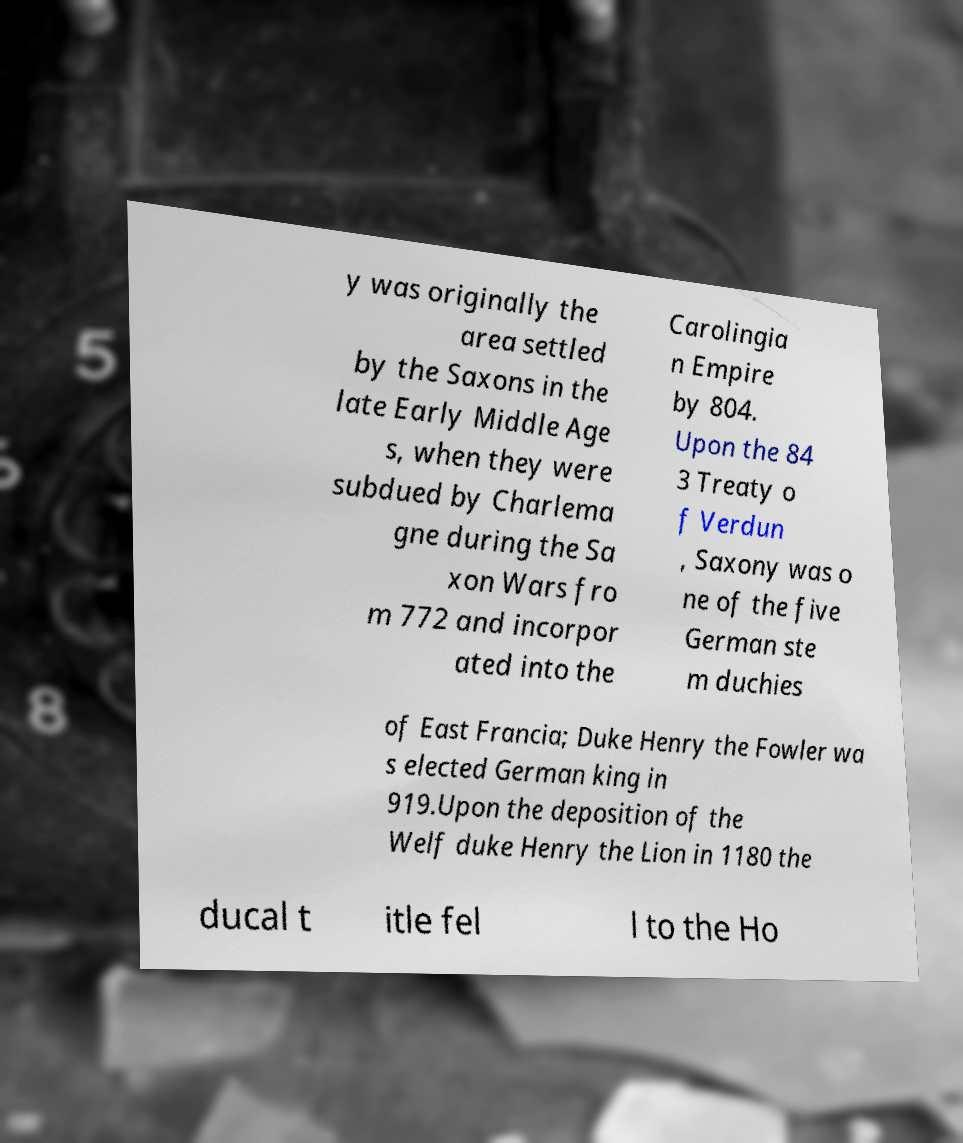What messages or text are displayed in this image? I need them in a readable, typed format. y was originally the area settled by the Saxons in the late Early Middle Age s, when they were subdued by Charlema gne during the Sa xon Wars fro m 772 and incorpor ated into the Carolingia n Empire by 804. Upon the 84 3 Treaty o f Verdun , Saxony was o ne of the five German ste m duchies of East Francia; Duke Henry the Fowler wa s elected German king in 919.Upon the deposition of the Welf duke Henry the Lion in 1180 the ducal t itle fel l to the Ho 